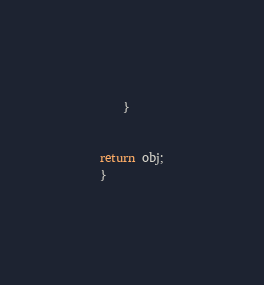<code> <loc_0><loc_0><loc_500><loc_500><_JavaScript_>    }


return obj;
}
</code> 